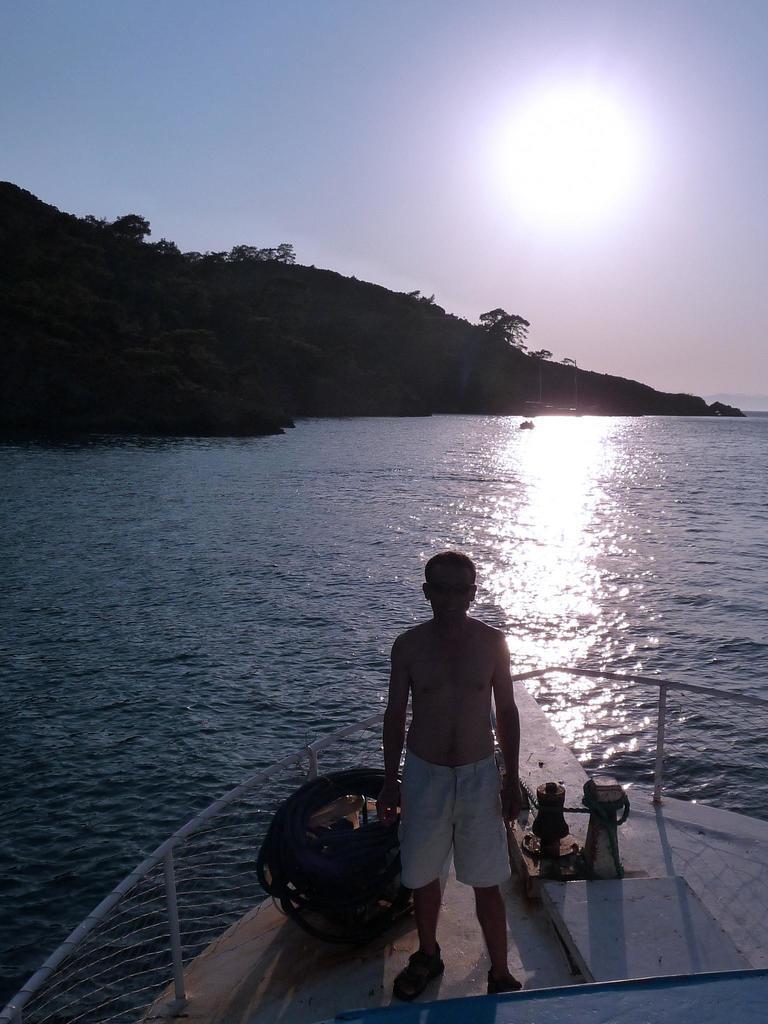Could you give a brief overview of what you see in this image? In this image, we can see a man in the boat. In the background, there are hills and at the bottom, there is water. 